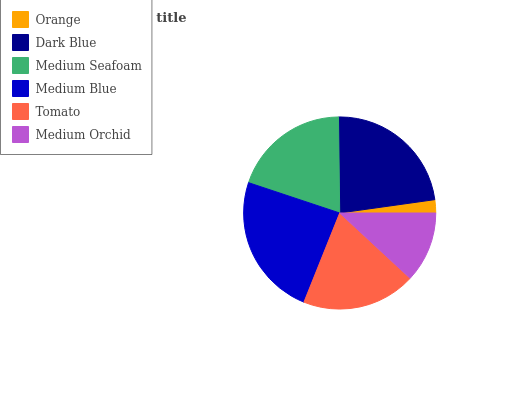Is Orange the minimum?
Answer yes or no. Yes. Is Medium Blue the maximum?
Answer yes or no. Yes. Is Dark Blue the minimum?
Answer yes or no. No. Is Dark Blue the maximum?
Answer yes or no. No. Is Dark Blue greater than Orange?
Answer yes or no. Yes. Is Orange less than Dark Blue?
Answer yes or no. Yes. Is Orange greater than Dark Blue?
Answer yes or no. No. Is Dark Blue less than Orange?
Answer yes or no. No. Is Medium Seafoam the high median?
Answer yes or no. Yes. Is Tomato the low median?
Answer yes or no. Yes. Is Medium Blue the high median?
Answer yes or no. No. Is Dark Blue the low median?
Answer yes or no. No. 